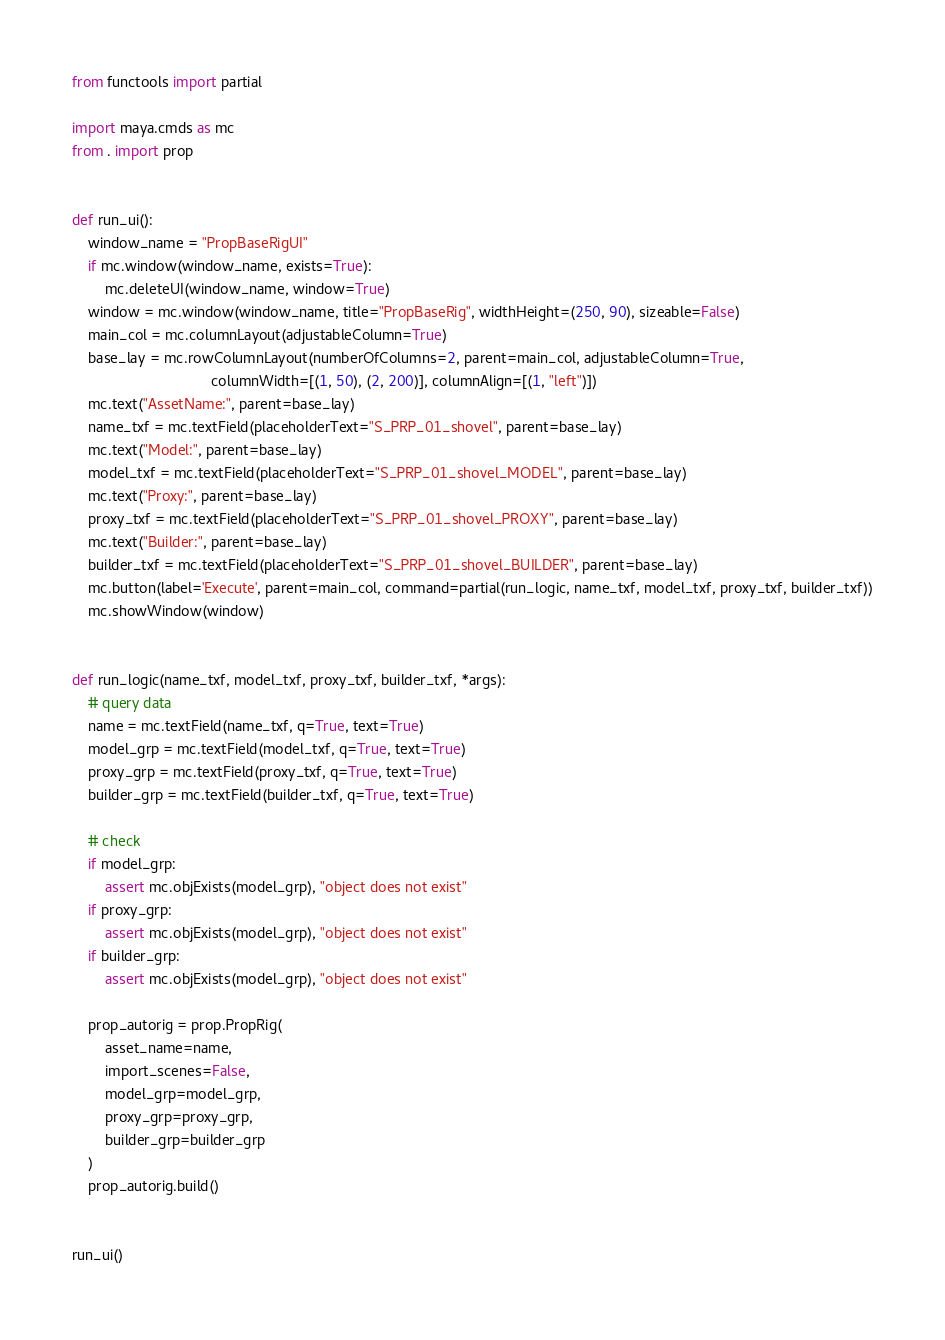Convert code to text. <code><loc_0><loc_0><loc_500><loc_500><_Python_>from functools import partial

import maya.cmds as mc
from . import prop


def run_ui():
    window_name = "PropBaseRigUI"
    if mc.window(window_name, exists=True):
        mc.deleteUI(window_name, window=True)
    window = mc.window(window_name, title="PropBaseRig", widthHeight=(250, 90), sizeable=False)
    main_col = mc.columnLayout(adjustableColumn=True)
    base_lay = mc.rowColumnLayout(numberOfColumns=2, parent=main_col, adjustableColumn=True,
                                  columnWidth=[(1, 50), (2, 200)], columnAlign=[(1, "left")])
    mc.text("AssetName:", parent=base_lay)
    name_txf = mc.textField(placeholderText="S_PRP_01_shovel", parent=base_lay)
    mc.text("Model:", parent=base_lay)
    model_txf = mc.textField(placeholderText="S_PRP_01_shovel_MODEL", parent=base_lay)
    mc.text("Proxy:", parent=base_lay)
    proxy_txf = mc.textField(placeholderText="S_PRP_01_shovel_PROXY", parent=base_lay)
    mc.text("Builder:", parent=base_lay)
    builder_txf = mc.textField(placeholderText="S_PRP_01_shovel_BUILDER", parent=base_lay)
    mc.button(label='Execute', parent=main_col, command=partial(run_logic, name_txf, model_txf, proxy_txf, builder_txf))
    mc.showWindow(window)


def run_logic(name_txf, model_txf, proxy_txf, builder_txf, *args):
    # query data
    name = mc.textField(name_txf, q=True, text=True)
    model_grp = mc.textField(model_txf, q=True, text=True)
    proxy_grp = mc.textField(proxy_txf, q=True, text=True)
    builder_grp = mc.textField(builder_txf, q=True, text=True)

    # check
    if model_grp:
        assert mc.objExists(model_grp), "object does not exist"
    if proxy_grp:
        assert mc.objExists(model_grp), "object does not exist"
    if builder_grp:
        assert mc.objExists(model_grp), "object does not exist"

    prop_autorig = prop.PropRig(
        asset_name=name,
        import_scenes=False,
        model_grp=model_grp,
        proxy_grp=proxy_grp,
        builder_grp=builder_grp
    )
    prop_autorig.build()


run_ui()
</code> 